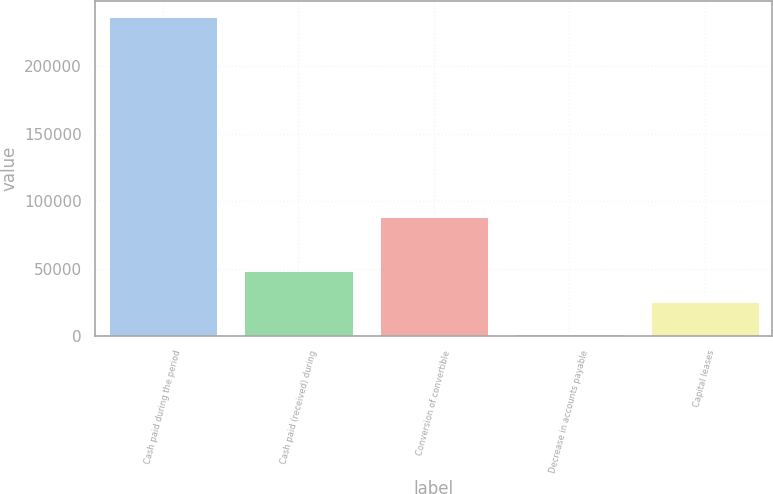Convert chart to OTSL. <chart><loc_0><loc_0><loc_500><loc_500><bar_chart><fcel>Cash paid during the period<fcel>Cash paid (received) during<fcel>Conversion of convertible<fcel>Decrease in accounts payable<fcel>Capital leases<nl><fcel>236389<fcel>48457<fcel>88085<fcel>1474<fcel>24965.5<nl></chart> 